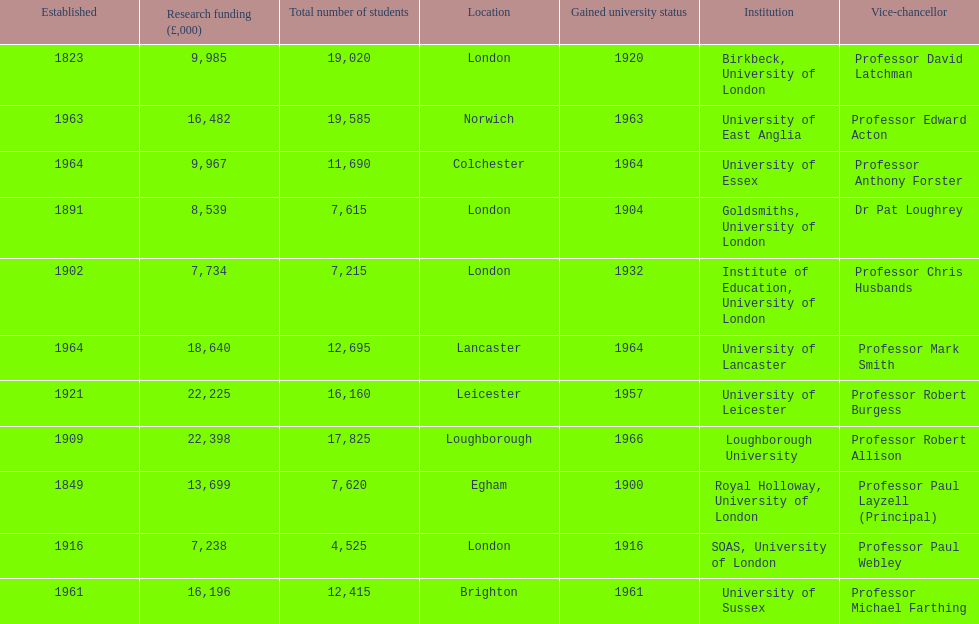How many of the institutions are located in london? 4. 